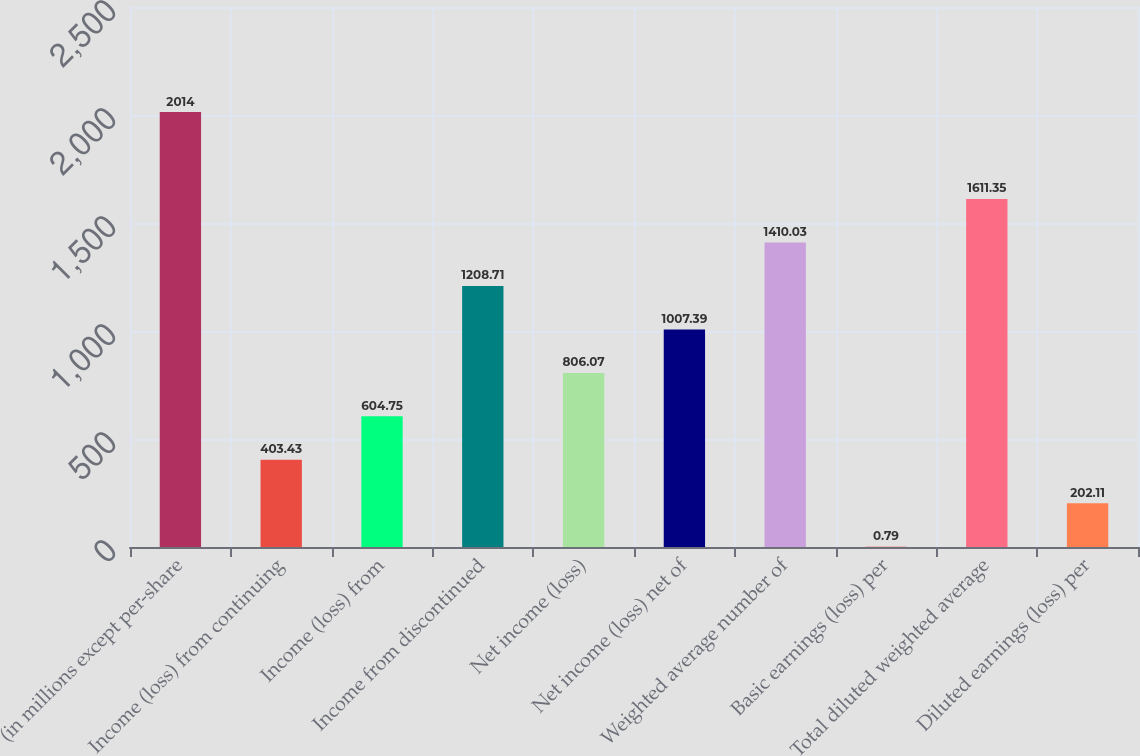Convert chart to OTSL. <chart><loc_0><loc_0><loc_500><loc_500><bar_chart><fcel>(in millions except per-share<fcel>Income (loss) from continuing<fcel>Income (loss) from<fcel>Income from discontinued<fcel>Net income (loss)<fcel>Net income (loss) net of<fcel>Weighted average number of<fcel>Basic earnings (loss) per<fcel>Total diluted weighted average<fcel>Diluted earnings (loss) per<nl><fcel>2014<fcel>403.43<fcel>604.75<fcel>1208.71<fcel>806.07<fcel>1007.39<fcel>1410.03<fcel>0.79<fcel>1611.35<fcel>202.11<nl></chart> 